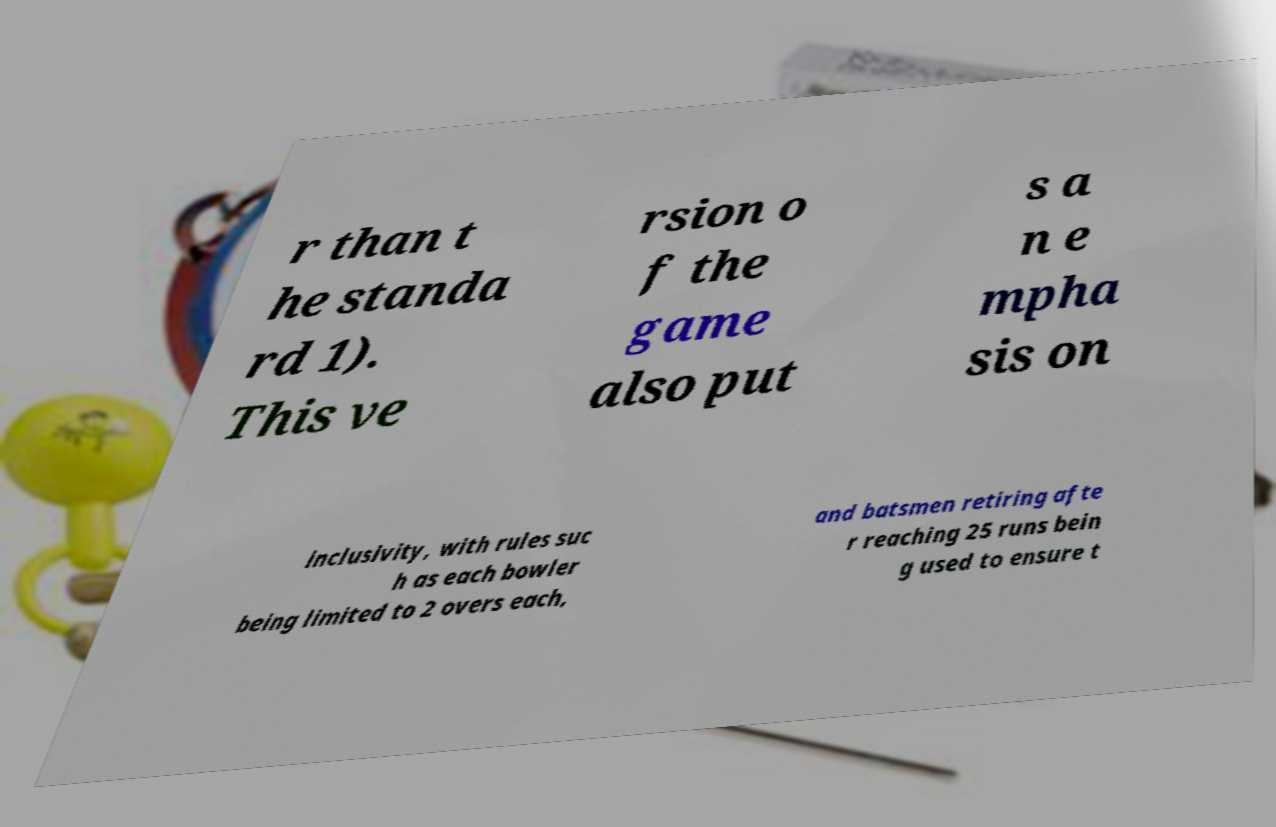Please read and relay the text visible in this image. What does it say? r than t he standa rd 1). This ve rsion o f the game also put s a n e mpha sis on inclusivity, with rules suc h as each bowler being limited to 2 overs each, and batsmen retiring afte r reaching 25 runs bein g used to ensure t 